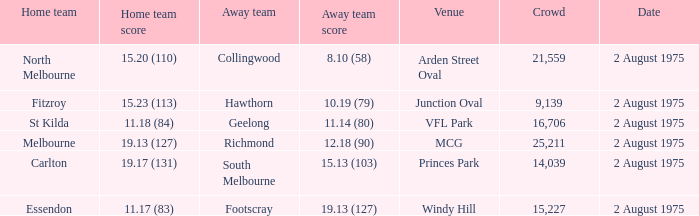Where did the home team score 11.18 (84)? VFL Park. 